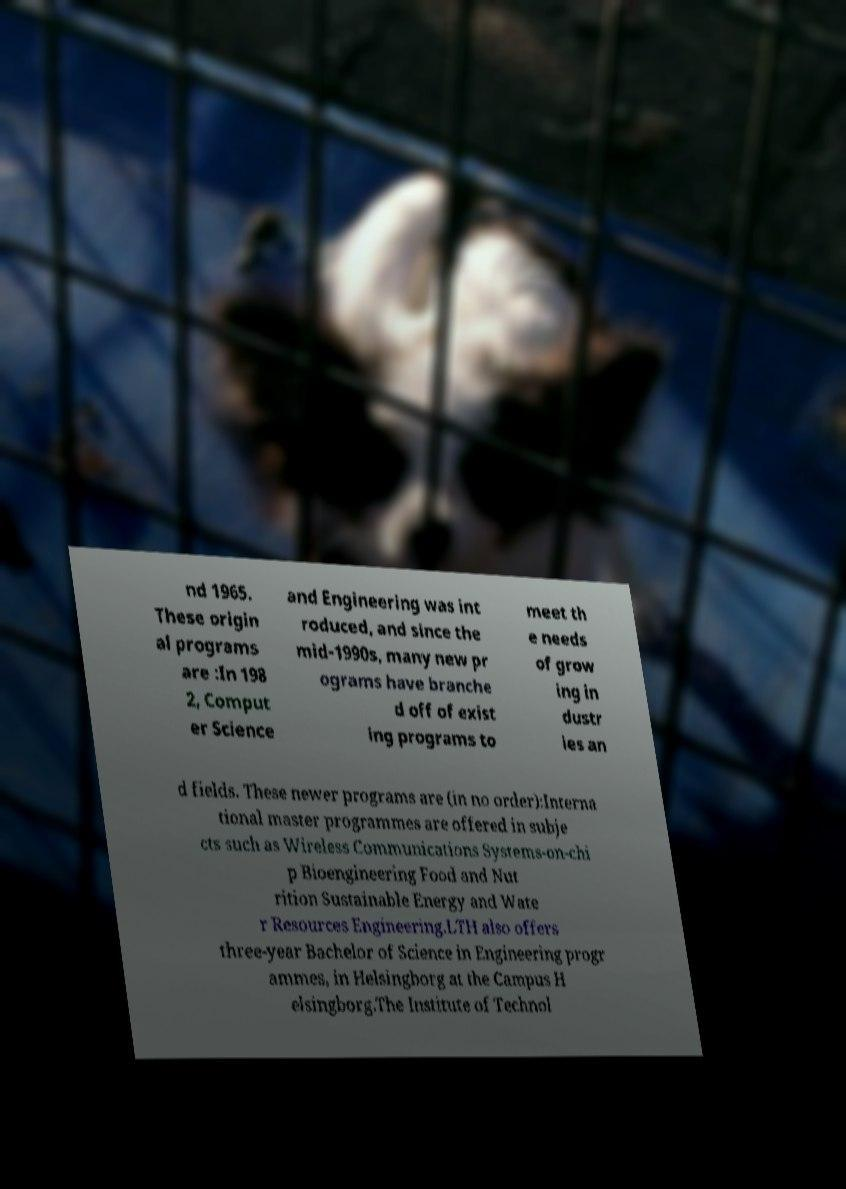Could you extract and type out the text from this image? nd 1965. These origin al programs are :In 198 2, Comput er Science and Engineering was int roduced, and since the mid-1990s, many new pr ograms have branche d off of exist ing programs to meet th e needs of grow ing in dustr ies an d fields. These newer programs are (in no order):Interna tional master programmes are offered in subje cts such as Wireless Communications Systems-on-chi p Bioengineering Food and Nut rition Sustainable Energy and Wate r Resources Engineering.LTH also offers three-year Bachelor of Science in Engineering progr ammes, in Helsingborg at the Campus H elsingborg.The Institute of Technol 